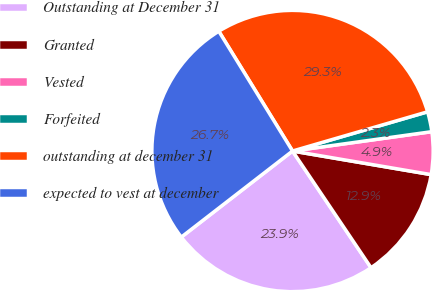Convert chart to OTSL. <chart><loc_0><loc_0><loc_500><loc_500><pie_chart><fcel>Outstanding at December 31<fcel>Granted<fcel>Vested<fcel>Forfeited<fcel>outstanding at december 31<fcel>expected to vest at december<nl><fcel>23.94%<fcel>12.89%<fcel>4.88%<fcel>2.3%<fcel>29.28%<fcel>26.7%<nl></chart> 